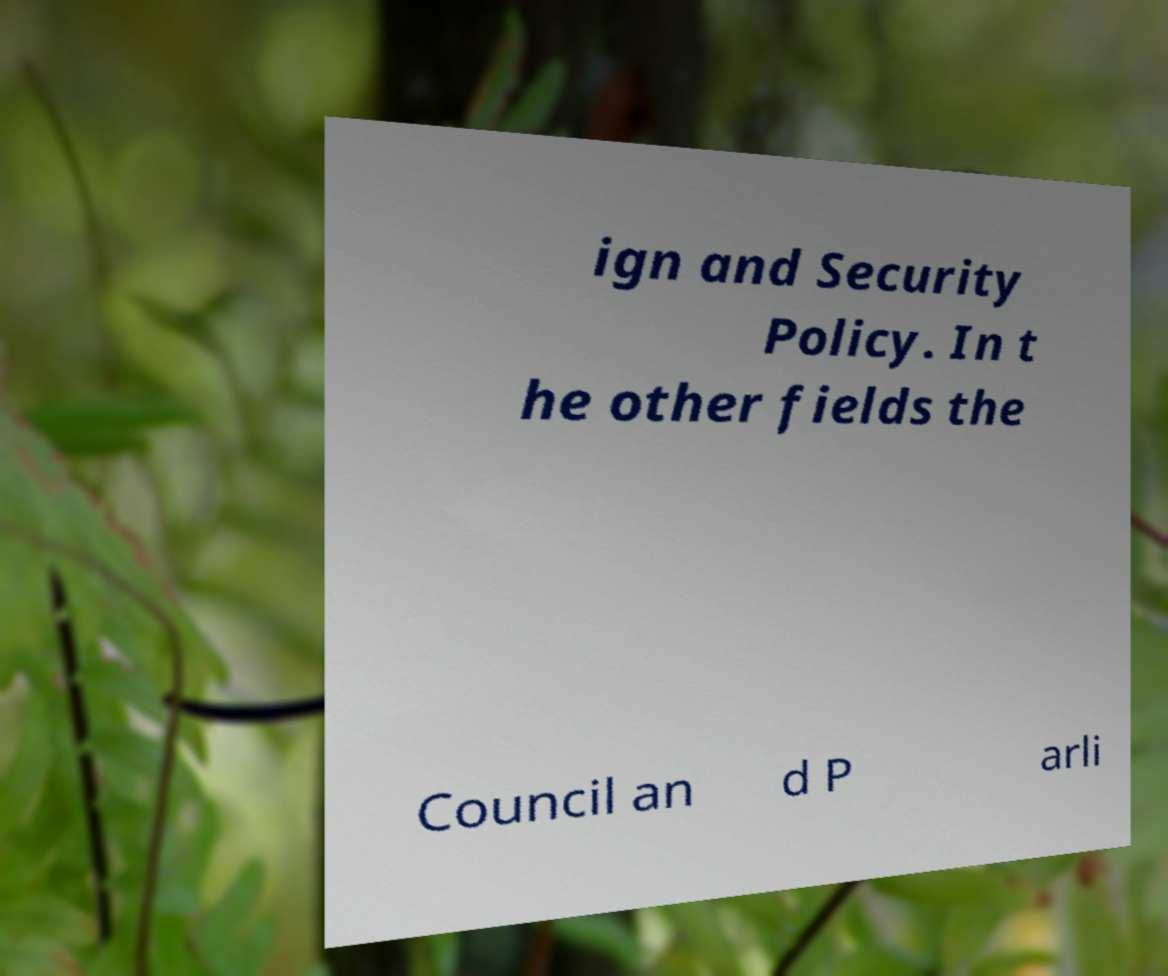Can you read and provide the text displayed in the image?This photo seems to have some interesting text. Can you extract and type it out for me? ign and Security Policy. In t he other fields the Council an d P arli 